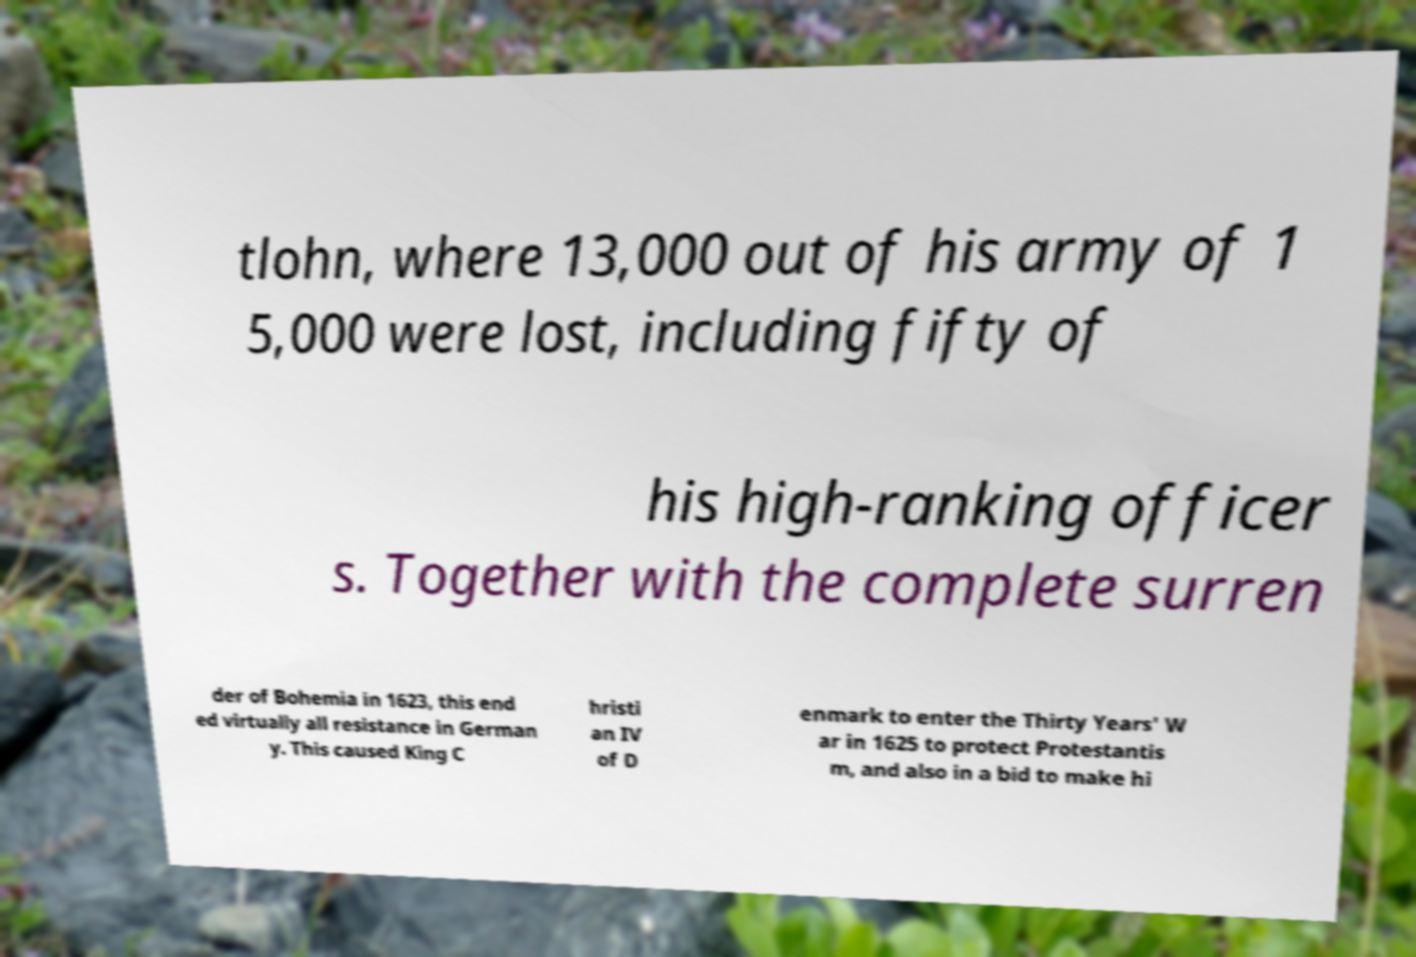Please read and relay the text visible in this image. What does it say? tlohn, where 13,000 out of his army of 1 5,000 were lost, including fifty of his high-ranking officer s. Together with the complete surren der of Bohemia in 1623, this end ed virtually all resistance in German y. This caused King C hristi an IV of D enmark to enter the Thirty Years' W ar in 1625 to protect Protestantis m, and also in a bid to make hi 